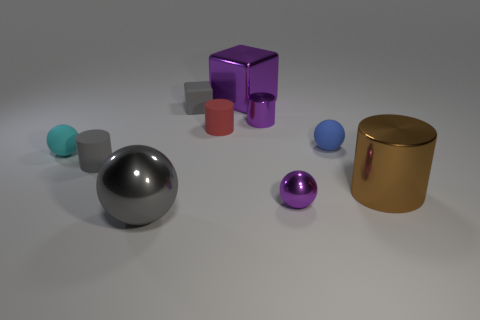Subtract all gray metal spheres. How many spheres are left? 3 Subtract all gray cylinders. How many cylinders are left? 3 Subtract all balls. How many objects are left? 6 Add 7 purple objects. How many purple objects are left? 10 Add 4 big purple shiny cubes. How many big purple shiny cubes exist? 5 Subtract 0 blue cylinders. How many objects are left? 10 Subtract all cyan spheres. Subtract all brown cylinders. How many spheres are left? 3 Subtract all balls. Subtract all small brown blocks. How many objects are left? 6 